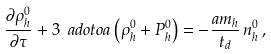Convert formula to latex. <formula><loc_0><loc_0><loc_500><loc_500>\frac { \partial \rho _ { h } ^ { 0 } } { \partial \tau } + 3 \ a d o t o a \left ( \rho _ { h } ^ { 0 } + P _ { h } ^ { 0 } \right ) = - \frac { a m _ { h } } { t _ { d } } \, n _ { h } ^ { 0 } \, ,</formula> 